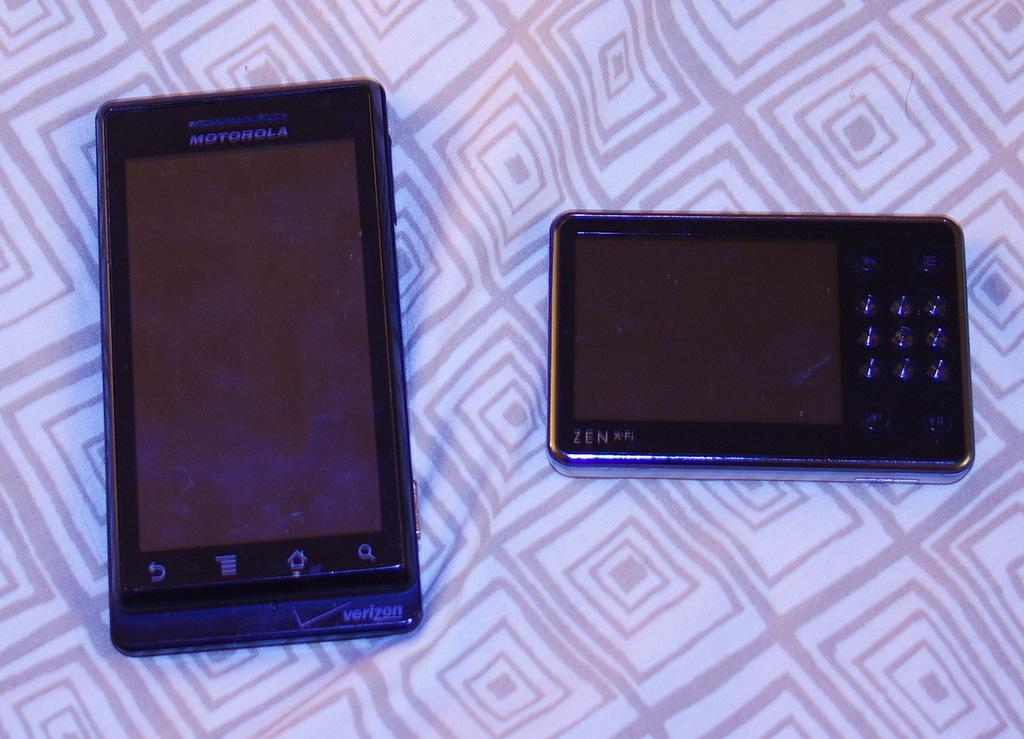<image>
Describe the image concisely. Two different sized cell phones on a sheet and the smallest phone is a zen. 